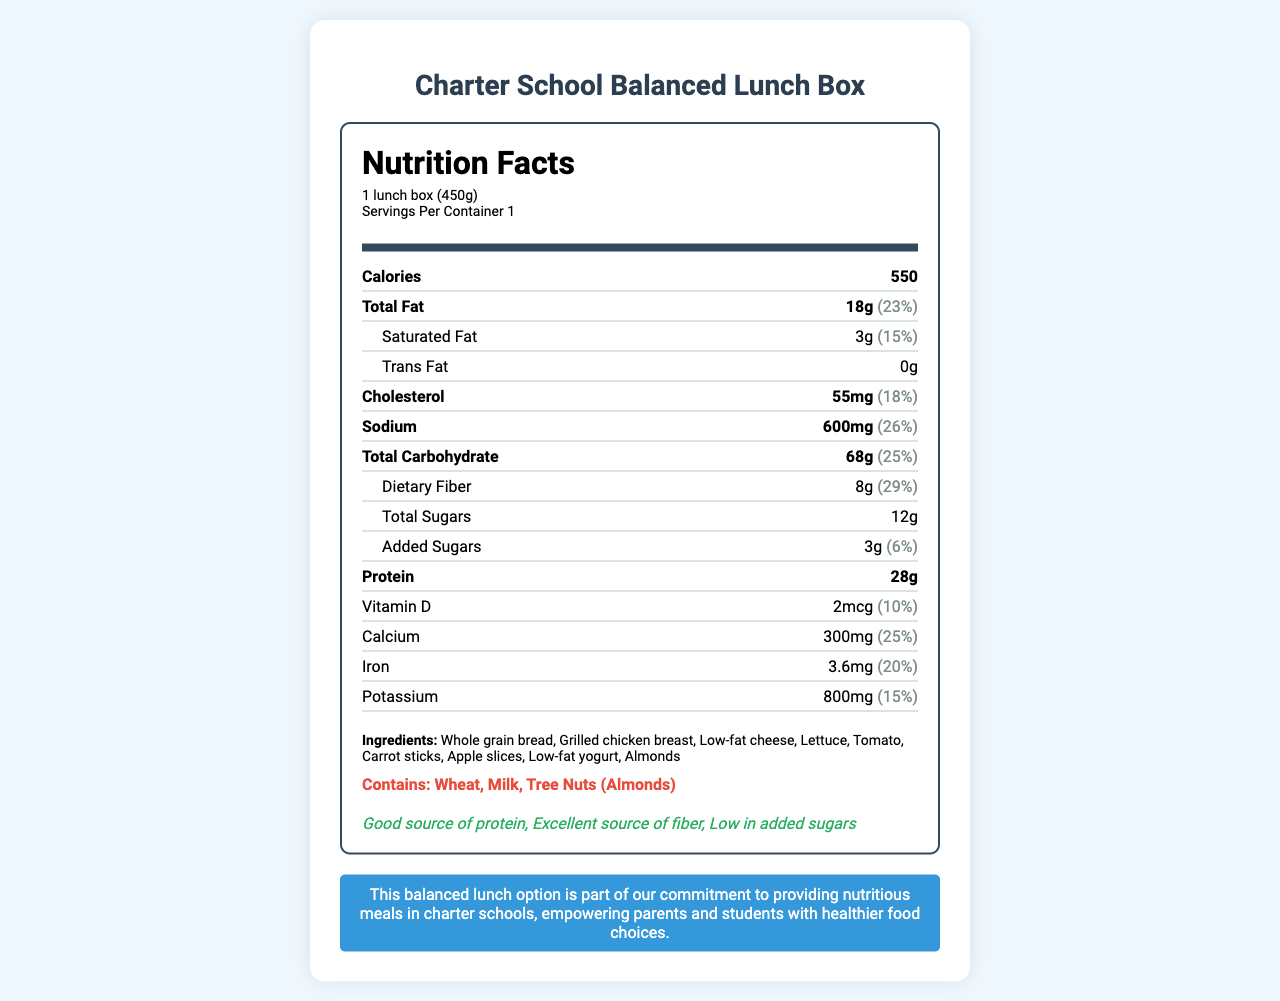what is the serving size of the Charter School Balanced Lunch Box? The serving size information is listed at the top of the Nutrition Facts under "Serving Size."
Answer: 1 lunch box (450g) how many calories are in one serving of this lunch box? The number of calories is indicated in the first main nutrition item under the "Calories" label.
Answer: 550 what is the total amount of dietary fiber in one serving? The total dietary fiber content can be found in the "Dietary Fiber" sub-item under the "Total Carbohydrate" section.
Answer: 8g what is the percentage daily value of calcium provided by this lunch box? The daily value percentage for calcium is listed in the nutrition item section as "25%."
Answer: 25% which ingredient is indicated as an allergen in this lunch box? The allergens are explicitly mentioned under the "allergen_info" section at the bottom of the document.
Answer: Wheat, Milk, Tree Nuts (Almonds) what are the sources of protein in this lunch box? Based on the ingredients list, these are the items that typically contain protein.
Answer: Grilled chicken breast, Low-fat cheese, Almonds which of the following vitamins is listed in the nutrition facts? A. Vitamin A B. Vitamin C C. Vitamin D D. Vitamin B12 The nutrition facts section only mentions Vitamin D, not the other options.
Answer: C. Vitamin D how much sodium does one lunch box contain? A. 400mg B. 500mg C. 600mg D. 700mg The sodium content is listed as 600mg in the nutrition facts section.
Answer: C. 600mg are there any trans fats in this lunch box? The amount of trans fats is listed as "0g" in the nutrition facts section, indicating there are no trans fats.
Answer: No is this lunch box an excellent source of dietary fiber? The document includes the health claim "Excellent source of fiber," which suggests it is high in dietary fiber.
Answer: Yes summarize the main idea of the Charter School Balanced Lunch Box document. This summary captures the overall intent and content of the document, highlighting its nutritional benefits and alignment with promoting healthier food choices in charter schools.
Answer: The Charter School Balanced Lunch Box is a nutritious meal option designed for school lunches, providing essential nutrients, promoting balanced eating, and supporting school choice. It includes whole grains, protein sources, fruits, and vegetables, and is low in added sugars and high in dietary fiber. how many different types of nuts are present in this lunch box? The document only lists "Almonds," a type of tree nut, and it does not specify if there are other types of nuts present or not.
Answer: Not enough information 